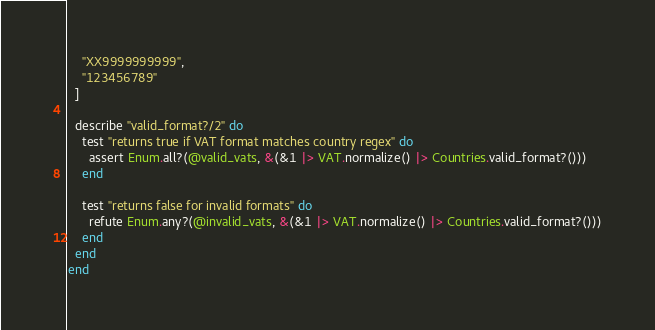<code> <loc_0><loc_0><loc_500><loc_500><_Elixir_>    "XX9999999999",
    "123456789"
  ]

  describe "valid_format?/2" do
    test "returns true if VAT format matches country regex" do
      assert Enum.all?(@valid_vats, &(&1 |> VAT.normalize() |> Countries.valid_format?()))
    end

    test "returns false for invalid formats" do
      refute Enum.any?(@invalid_vats, &(&1 |> VAT.normalize() |> Countries.valid_format?()))
    end
  end
end
</code> 